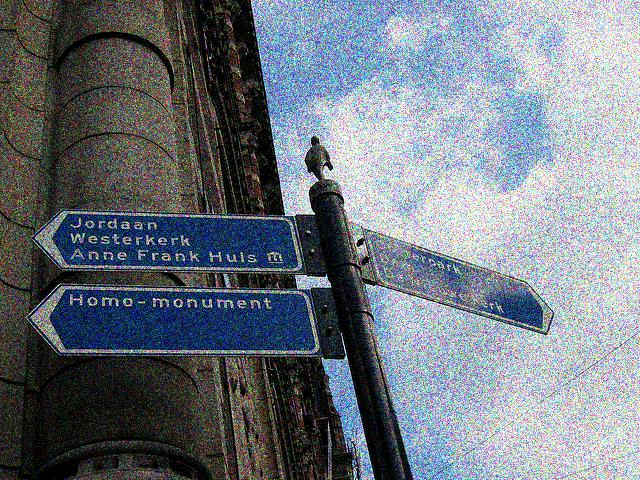How does the image composition affect the perception of the place shown? The composition with the street signs in the foreground and the building facade in the background suggests a bustling, urban environment. The angle looking up at the signs gives a sense of exploration and discovery, inviting viewers to imagine walking through the streets and finding their way around this possibly historical area. The high contrast and saturated colors also add a dynamic and somewhat artistic feel to the scene. 